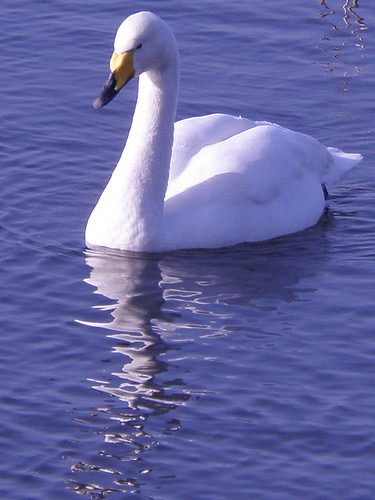<image>
Is there a water on the duck? No. The water is not positioned on the duck. They may be near each other, but the water is not supported by or resting on top of the duck. Is the ripples under the duck? Yes. The ripples is positioned underneath the duck, with the duck above it in the vertical space. 